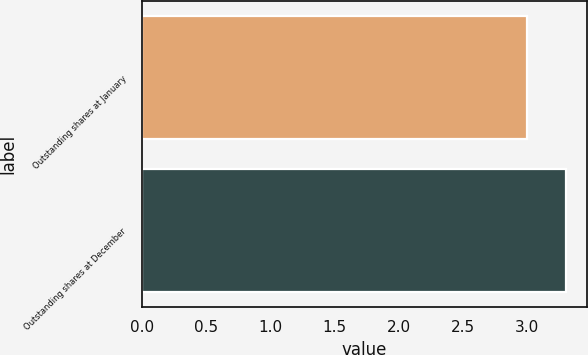<chart> <loc_0><loc_0><loc_500><loc_500><bar_chart><fcel>Outstanding shares at January<fcel>Outstanding shares at December<nl><fcel>3<fcel>3.3<nl></chart> 